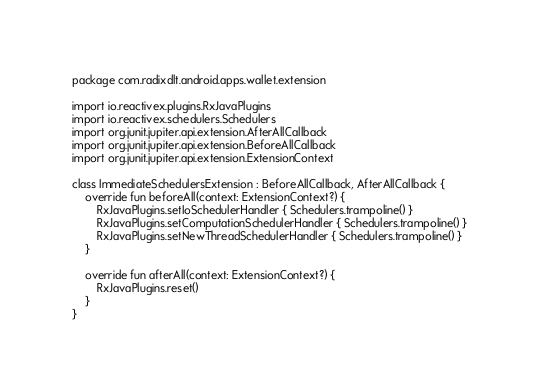Convert code to text. <code><loc_0><loc_0><loc_500><loc_500><_Kotlin_>package com.radixdlt.android.apps.wallet.extension

import io.reactivex.plugins.RxJavaPlugins
import io.reactivex.schedulers.Schedulers
import org.junit.jupiter.api.extension.AfterAllCallback
import org.junit.jupiter.api.extension.BeforeAllCallback
import org.junit.jupiter.api.extension.ExtensionContext

class ImmediateSchedulersExtension : BeforeAllCallback, AfterAllCallback {
    override fun beforeAll(context: ExtensionContext?) {
        RxJavaPlugins.setIoSchedulerHandler { Schedulers.trampoline() }
        RxJavaPlugins.setComputationSchedulerHandler { Schedulers.trampoline() }
        RxJavaPlugins.setNewThreadSchedulerHandler { Schedulers.trampoline() }
    }

    override fun afterAll(context: ExtensionContext?) {
        RxJavaPlugins.reset()
    }
}
</code> 